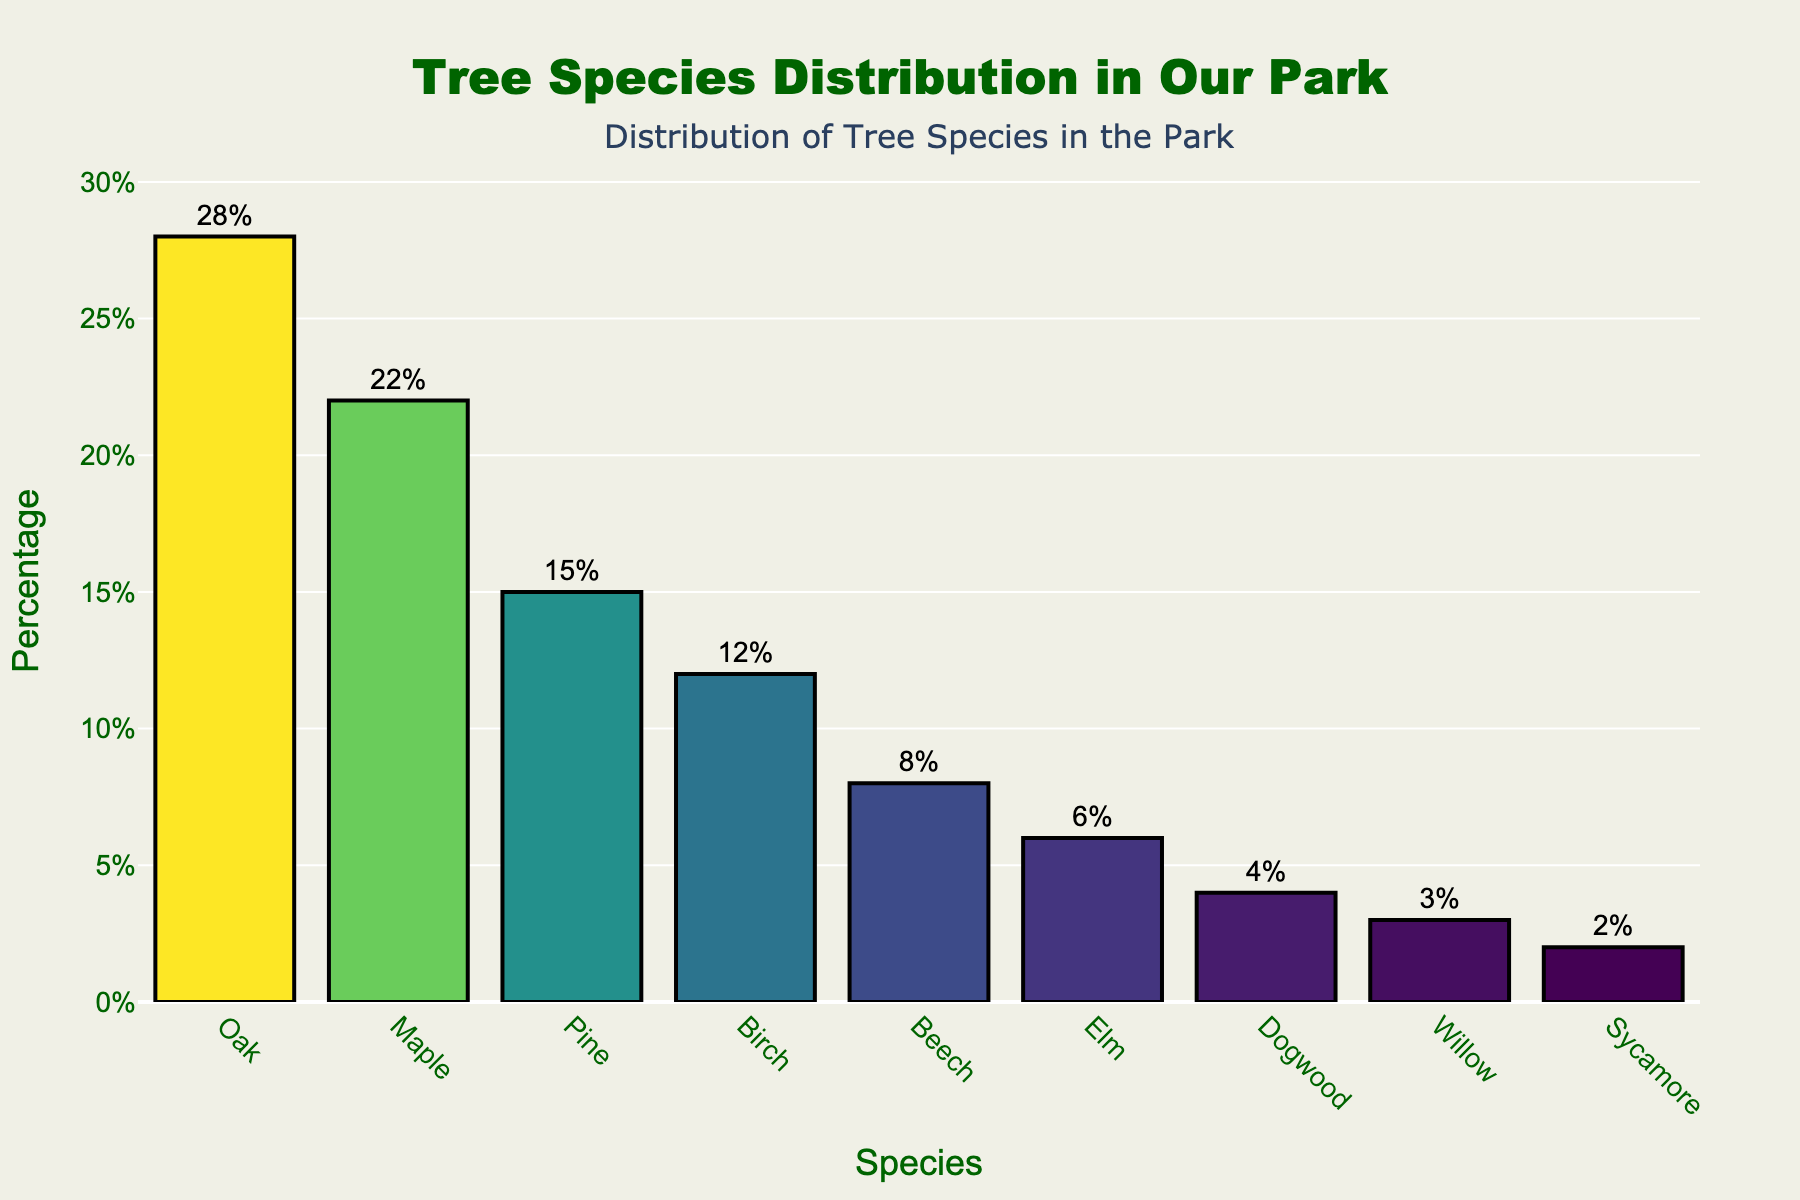Which tree species has the highest percentage in the park? The tallest bar represents the tree species with the highest percentage, which is Oak at 28%.
Answer: Oak Which tree species has the lowest percentage in the park? The shortest bar corresponds to the tree species with the lowest percentage, which is Sycamore at 2%.
Answer: Sycamore What is the percentage difference between Oak and Maple? Subtract the percentage of Maple (22%) from Oak (28%): 28% - 22% = 6%.
Answer: 6% How many tree species have a percentage greater than 10%? From the plot, Oak (28%), Maple (22%), Pine (15%), and Birch (12%) all have percentages greater than 10%, which totals to 4 species.
Answer: 4 Are there more Pine trees or Birch trees in the park? Compare the height of the bars for Pine (15%) and Birch (12%), showing that there are more Pine trees.
Answer: Pine What is the combined percentage of Beech, Elm, and Dogwood trees? Sum the individual percentages: Beech (8%) + Elm (6%) + Dogwood (4%) = 18%.
Answer: 18% Which tree species is represented by a dark color in the bar chart? The color scale, which is darker for lower percentages, shows Sycamore (2%) and Willow (3%) represented by darker colors.
Answer: Sycamore, Willow What is the average percentage of Oak, Maple, and Pine trees? Add their percentages and divide by 3: (28 + 22 + 15) / 3 = 21.67%.
Answer: 21.67% Which has a higher percentage: the sum of Elm and Dogwood, or just Birch? Calculate both: Elm (6%) + Dogwood (4%) = 10%, and compare it with Birch (12%). Birch has a higher percentage.
Answer: Birch How does the percentage of Willow trees compare to Elm trees? Willow has a percentage of 3% and Elm has 6%, so Willow's percentage is half of Elm's.
Answer: Half 